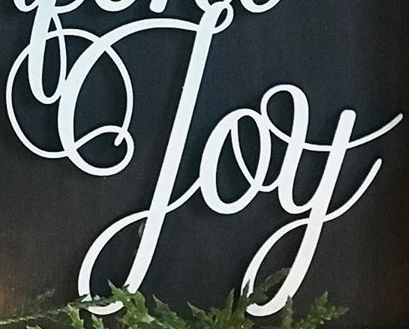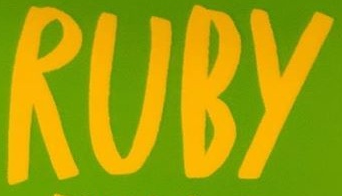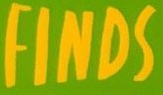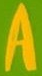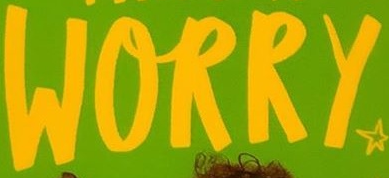What text is displayed in these images sequentially, separated by a semicolon? Joy; RUBY; FINDS; A; WORRY 